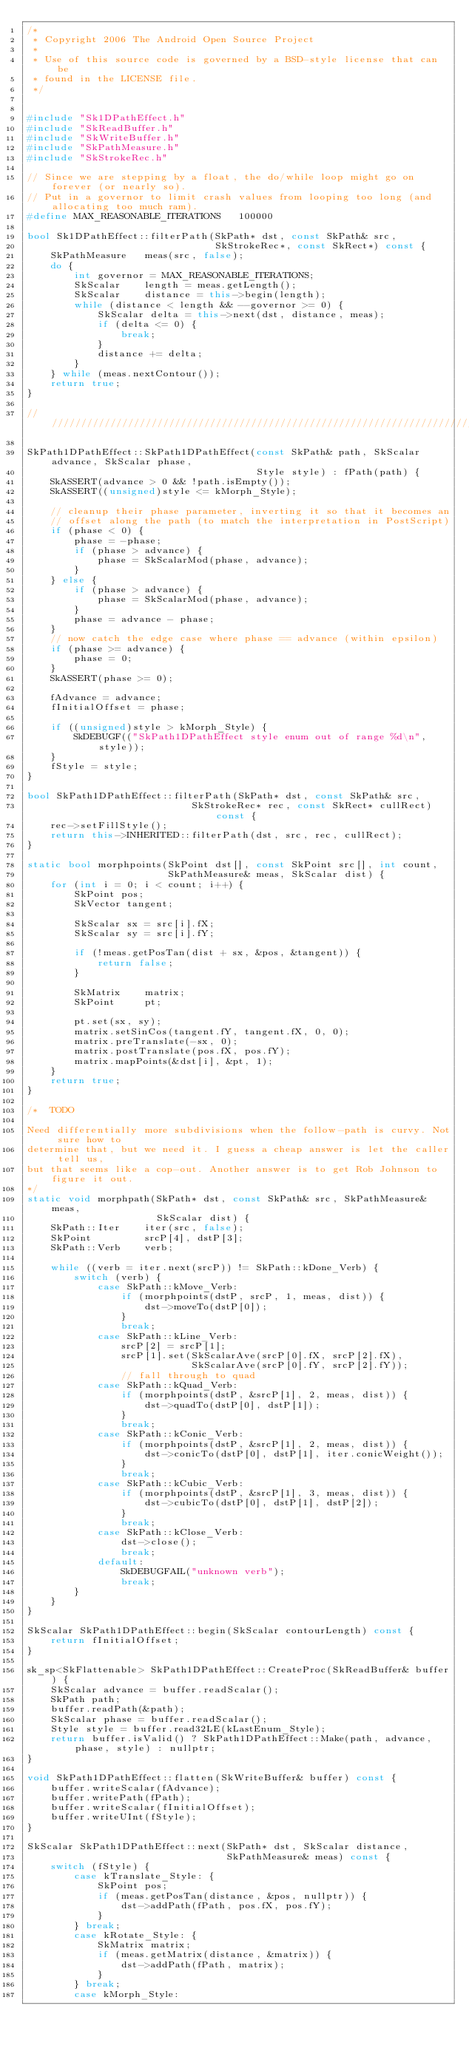<code> <loc_0><loc_0><loc_500><loc_500><_C++_>/*
 * Copyright 2006 The Android Open Source Project
 *
 * Use of this source code is governed by a BSD-style license that can be
 * found in the LICENSE file.
 */


#include "Sk1DPathEffect.h"
#include "SkReadBuffer.h"
#include "SkWriteBuffer.h"
#include "SkPathMeasure.h"
#include "SkStrokeRec.h"

// Since we are stepping by a float, the do/while loop might go on forever (or nearly so).
// Put in a governor to limit crash values from looping too long (and allocating too much ram).
#define MAX_REASONABLE_ITERATIONS   100000

bool Sk1DPathEffect::filterPath(SkPath* dst, const SkPath& src,
                                SkStrokeRec*, const SkRect*) const {
    SkPathMeasure   meas(src, false);
    do {
        int governor = MAX_REASONABLE_ITERATIONS;
        SkScalar    length = meas.getLength();
        SkScalar    distance = this->begin(length);
        while (distance < length && --governor >= 0) {
            SkScalar delta = this->next(dst, distance, meas);
            if (delta <= 0) {
                break;
            }
            distance += delta;
        }
    } while (meas.nextContour());
    return true;
}

///////////////////////////////////////////////////////////////////////////////

SkPath1DPathEffect::SkPath1DPathEffect(const SkPath& path, SkScalar advance, SkScalar phase,
                                       Style style) : fPath(path) {
    SkASSERT(advance > 0 && !path.isEmpty());
    SkASSERT((unsigned)style <= kMorph_Style);

    // cleanup their phase parameter, inverting it so that it becomes an
    // offset along the path (to match the interpretation in PostScript)
    if (phase < 0) {
        phase = -phase;
        if (phase > advance) {
            phase = SkScalarMod(phase, advance);
        }
    } else {
        if (phase > advance) {
            phase = SkScalarMod(phase, advance);
        }
        phase = advance - phase;
    }
    // now catch the edge case where phase == advance (within epsilon)
    if (phase >= advance) {
        phase = 0;
    }
    SkASSERT(phase >= 0);

    fAdvance = advance;
    fInitialOffset = phase;

    if ((unsigned)style > kMorph_Style) {
        SkDEBUGF(("SkPath1DPathEffect style enum out of range %d\n", style));
    }
    fStyle = style;
}

bool SkPath1DPathEffect::filterPath(SkPath* dst, const SkPath& src,
                            SkStrokeRec* rec, const SkRect* cullRect) const {
    rec->setFillStyle();
    return this->INHERITED::filterPath(dst, src, rec, cullRect);
}

static bool morphpoints(SkPoint dst[], const SkPoint src[], int count,
                        SkPathMeasure& meas, SkScalar dist) {
    for (int i = 0; i < count; i++) {
        SkPoint pos;
        SkVector tangent;

        SkScalar sx = src[i].fX;
        SkScalar sy = src[i].fY;

        if (!meas.getPosTan(dist + sx, &pos, &tangent)) {
            return false;
        }

        SkMatrix    matrix;
        SkPoint     pt;

        pt.set(sx, sy);
        matrix.setSinCos(tangent.fY, tangent.fX, 0, 0);
        matrix.preTranslate(-sx, 0);
        matrix.postTranslate(pos.fX, pos.fY);
        matrix.mapPoints(&dst[i], &pt, 1);
    }
    return true;
}

/*  TODO

Need differentially more subdivisions when the follow-path is curvy. Not sure how to
determine that, but we need it. I guess a cheap answer is let the caller tell us,
but that seems like a cop-out. Another answer is to get Rob Johnson to figure it out.
*/
static void morphpath(SkPath* dst, const SkPath& src, SkPathMeasure& meas,
                      SkScalar dist) {
    SkPath::Iter    iter(src, false);
    SkPoint         srcP[4], dstP[3];
    SkPath::Verb    verb;

    while ((verb = iter.next(srcP)) != SkPath::kDone_Verb) {
        switch (verb) {
            case SkPath::kMove_Verb:
                if (morphpoints(dstP, srcP, 1, meas, dist)) {
                    dst->moveTo(dstP[0]);
                }
                break;
            case SkPath::kLine_Verb:
                srcP[2] = srcP[1];
                srcP[1].set(SkScalarAve(srcP[0].fX, srcP[2].fX),
                            SkScalarAve(srcP[0].fY, srcP[2].fY));
                // fall through to quad
            case SkPath::kQuad_Verb:
                if (morphpoints(dstP, &srcP[1], 2, meas, dist)) {
                    dst->quadTo(dstP[0], dstP[1]);
                }
                break;
            case SkPath::kConic_Verb:
                if (morphpoints(dstP, &srcP[1], 2, meas, dist)) {
                    dst->conicTo(dstP[0], dstP[1], iter.conicWeight());
                }
                break;
            case SkPath::kCubic_Verb:
                if (morphpoints(dstP, &srcP[1], 3, meas, dist)) {
                    dst->cubicTo(dstP[0], dstP[1], dstP[2]);
                }
                break;
            case SkPath::kClose_Verb:
                dst->close();
                break;
            default:
                SkDEBUGFAIL("unknown verb");
                break;
        }
    }
}

SkScalar SkPath1DPathEffect::begin(SkScalar contourLength) const {
    return fInitialOffset;
}

sk_sp<SkFlattenable> SkPath1DPathEffect::CreateProc(SkReadBuffer& buffer) {
    SkScalar advance = buffer.readScalar();
    SkPath path;
    buffer.readPath(&path);
    SkScalar phase = buffer.readScalar();
    Style style = buffer.read32LE(kLastEnum_Style);
    return buffer.isValid() ? SkPath1DPathEffect::Make(path, advance, phase, style) : nullptr;
}

void SkPath1DPathEffect::flatten(SkWriteBuffer& buffer) const {
    buffer.writeScalar(fAdvance);
    buffer.writePath(fPath);
    buffer.writeScalar(fInitialOffset);
    buffer.writeUInt(fStyle);
}

SkScalar SkPath1DPathEffect::next(SkPath* dst, SkScalar distance,
                                  SkPathMeasure& meas) const {
    switch (fStyle) {
        case kTranslate_Style: {
            SkPoint pos;
            if (meas.getPosTan(distance, &pos, nullptr)) {
                dst->addPath(fPath, pos.fX, pos.fY);
            }
        } break;
        case kRotate_Style: {
            SkMatrix matrix;
            if (meas.getMatrix(distance, &matrix)) {
                dst->addPath(fPath, matrix);
            }
        } break;
        case kMorph_Style:</code> 